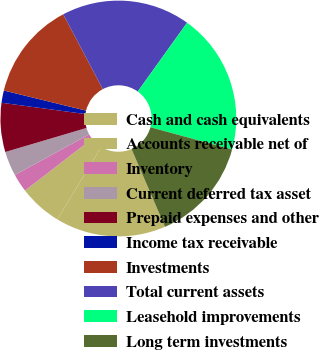Convert chart to OTSL. <chart><loc_0><loc_0><loc_500><loc_500><pie_chart><fcel>Cash and cash equivalents<fcel>Accounts receivable net of<fcel>Inventory<fcel>Current deferred tax asset<fcel>Prepaid expenses and other<fcel>Income tax receivable<fcel>Investments<fcel>Total current assets<fcel>Leasehold improvements<fcel>Long term investments<nl><fcel>15.13%<fcel>5.88%<fcel>2.52%<fcel>3.36%<fcel>6.72%<fcel>1.68%<fcel>13.44%<fcel>17.65%<fcel>19.33%<fcel>14.29%<nl></chart> 